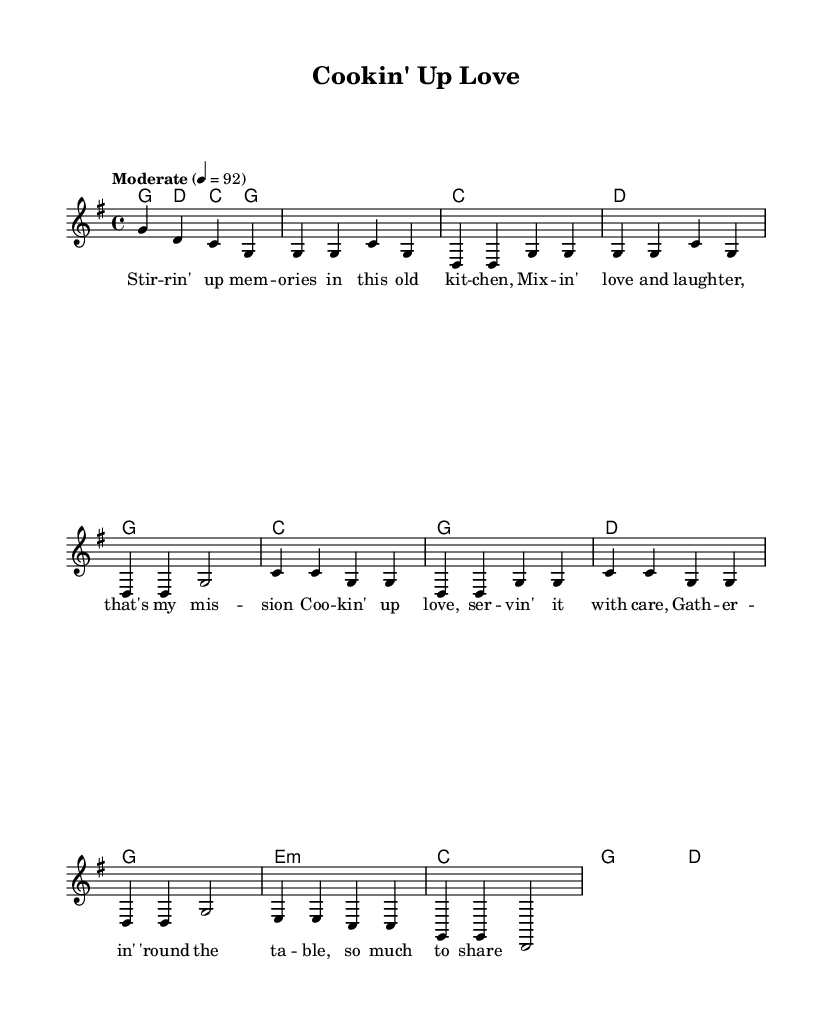What is the key signature of this music? The key signature is G major, which has one sharp (F#). This can be identified by looking at the key signature indicated at the beginning of the sheet music.
Answer: G major What is the time signature of this song? The time signature is 4/4, which indicates there are four beats in each measure and the quarter note gets one beat. This is usually found at the beginning of the score along with the key signature.
Answer: 4/4 What is the tempo marking for this piece? The tempo marking is "Moderate" and indicated as quarter note = 92. This is provided in the tempo instruction at the beginning of the music.
Answer: Moderate What is the first note of the melody? The first note of the melody is G. This can be determined by looking at the first note in the melody line following the global settings.
Answer: G How many measures are in the chorus? The chorus consists of four measures. By counting the measures in the chorus section of the sheet music, each line typically contains two measures, leading to a total of four when combined.
Answer: 4 Which section has the lyrics "Cookin' up love, servin' it with care"? This line appears in the chorus section, which is clearly segmented from the verse and other parts. The lyrics are directly under the melodic line correspondingly.
Answer: Chorus What type of chord is used in the bridge? The bridge uses an E minor chord as indicated by "e1:m" in the chord names. This is found in the harmonies section of the sheet music.
Answer: E minor 